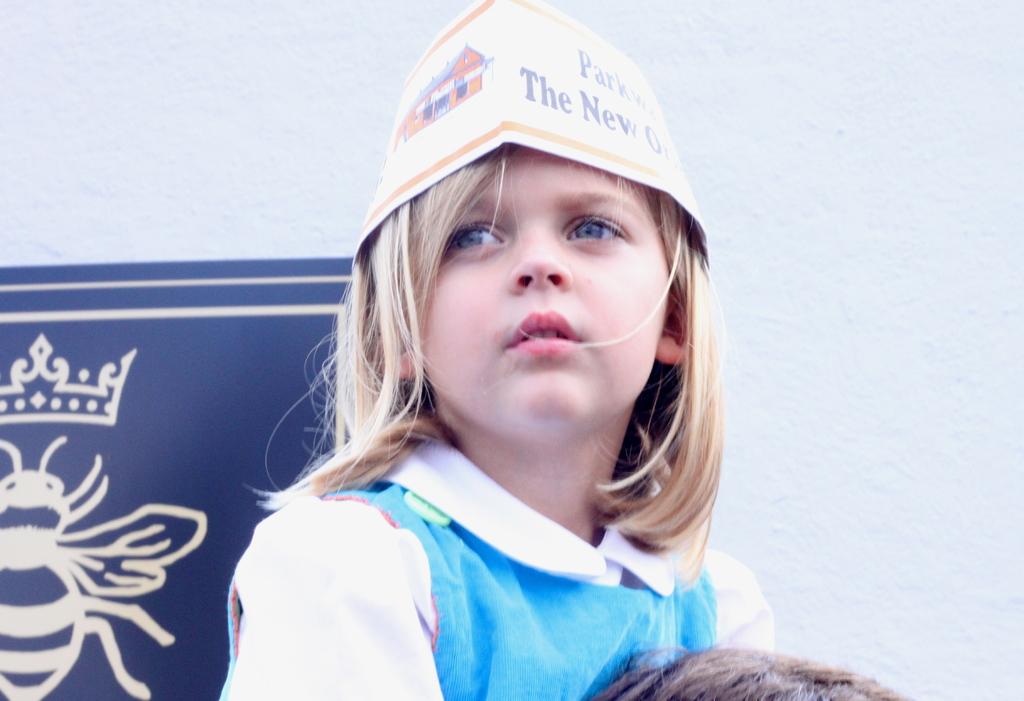What does it say on her hat next to "the"?
Ensure brevity in your answer.  New. What does it say on the top line of her hat?
Keep it short and to the point. Parkway. 